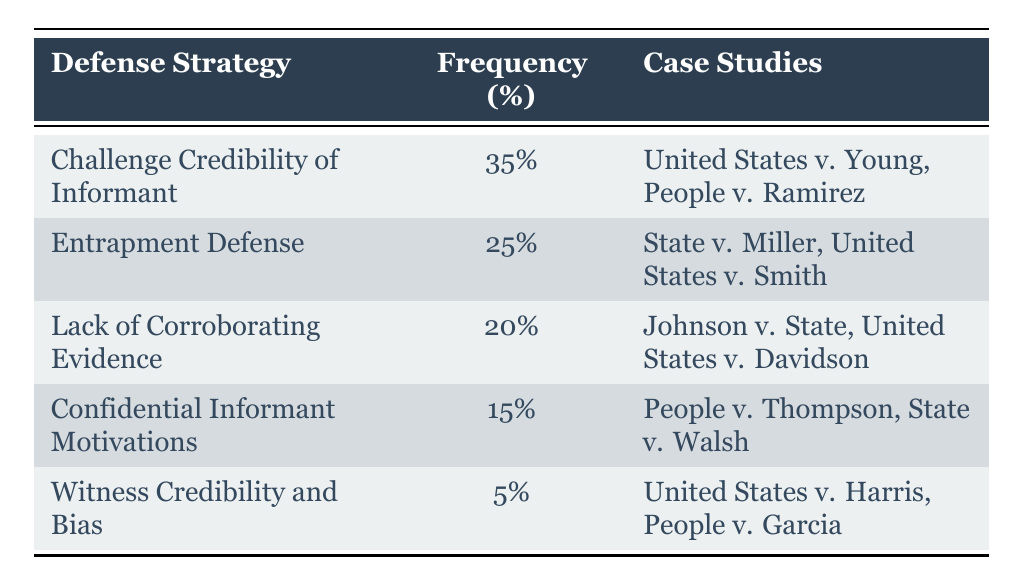What is the frequency percentage for the defense strategy "Challenge Credibility of Informant"? The table shows that "Challenge Credibility of Informant" has a frequency percentage of 35%.
Answer: 35% Which defense strategy has the lowest frequency percentage? By examining the table, the strategy with the lowest frequency percentage is "Witness Credibility and Bias," which has a frequency of 5%.
Answer: Witness Credibility and Bias How many case studies are associated with the "Entrapment Defense" strategy? The table lists "Entrapment Defense" alongside two case studies: "State v. Miller" and "United States v. Smith." Therefore, there are 2 case studies.
Answer: 2 What is the total frequency percentage of the top two defense strategies? The top two strategies are "Challenge Credibility of Informant" at 35% and "Entrapment Defense" at 25%. Adding these percentages together gives 35% + 25% = 60%.
Answer: 60% Is it true that "Confidential Informant Motivations" has a higher frequency percentage than "Lack of Corroborating Evidence"? Comparing the frequency percentages, "Confidential Informant Motivations" at 15% is lower than "Lack of Corroborating Evidence," which is at 20%. Thus, it is false that the former has a higher percentage.
Answer: No If you combine the frequencies of "Challenge Credibility of Informant" and "Lack of Corroborating Evidence," how much do you get? The sum of the frequencies is 35% (from "Challenge Credibility of Informant") and 20% (from "Lack of Corroborating Evidence"). This gives a total of 35% + 20% = 55%.
Answer: 55% What percentage of the strategies listed focus on the credibility of informants in some way? The strategies "Challenge Credibility of Informant" (35%) and "Witness Credibility and Bias" (5%) both focus on informant credibility, summing to 35% + 5% = 40%.
Answer: 40% How many defense strategies have a frequency percentage of 15% or lower? There are two strategies with a frequency percentage of 15% or lower: "Confidential Informant Motivations" at 15% and "Witness Credibility and Bias" at 5%. Therefore, the total count is 2.
Answer: 2 